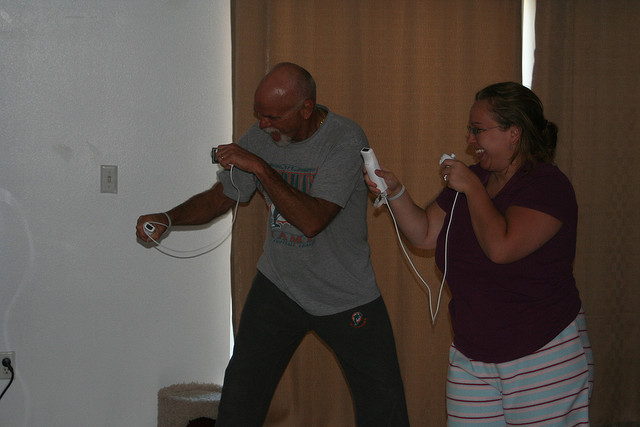<image>What style of shorts is the man wearing? The man is not wearing shorts. What team is on the man's shirt? I am not sure. The team on the man's shirt could be the Miami Dolphins, Celtics, or Braves. What color is the lady's jacket? It is ambiguous what color the lady's jacket is. It can be seen as purple, black or maroon. However, it's also stated that she isn't wearing one. Are they playing the video games drunk? The answer is ambiguous. It's not clear if they are playing video games drunk or not. What style of shorts is the man wearing? It is unknown what style of shorts the man is wearing. He is not wearing shorts in the image. Are they playing the video games drunk? I don't know if they are playing the video games drunk. It can be both yes or no. What team is on the man's shirt? I don't know what team is on the man's shirt. It can be any of ['braves', 'dolphins', 'miami dolphins', 'celtics', 'bills', 'amt', '0', 'miami']. What color is the lady's jacket? The color of the lady's jacket is not clear. It can be seen as purple, black, maroon, or she isn't wearing one. 